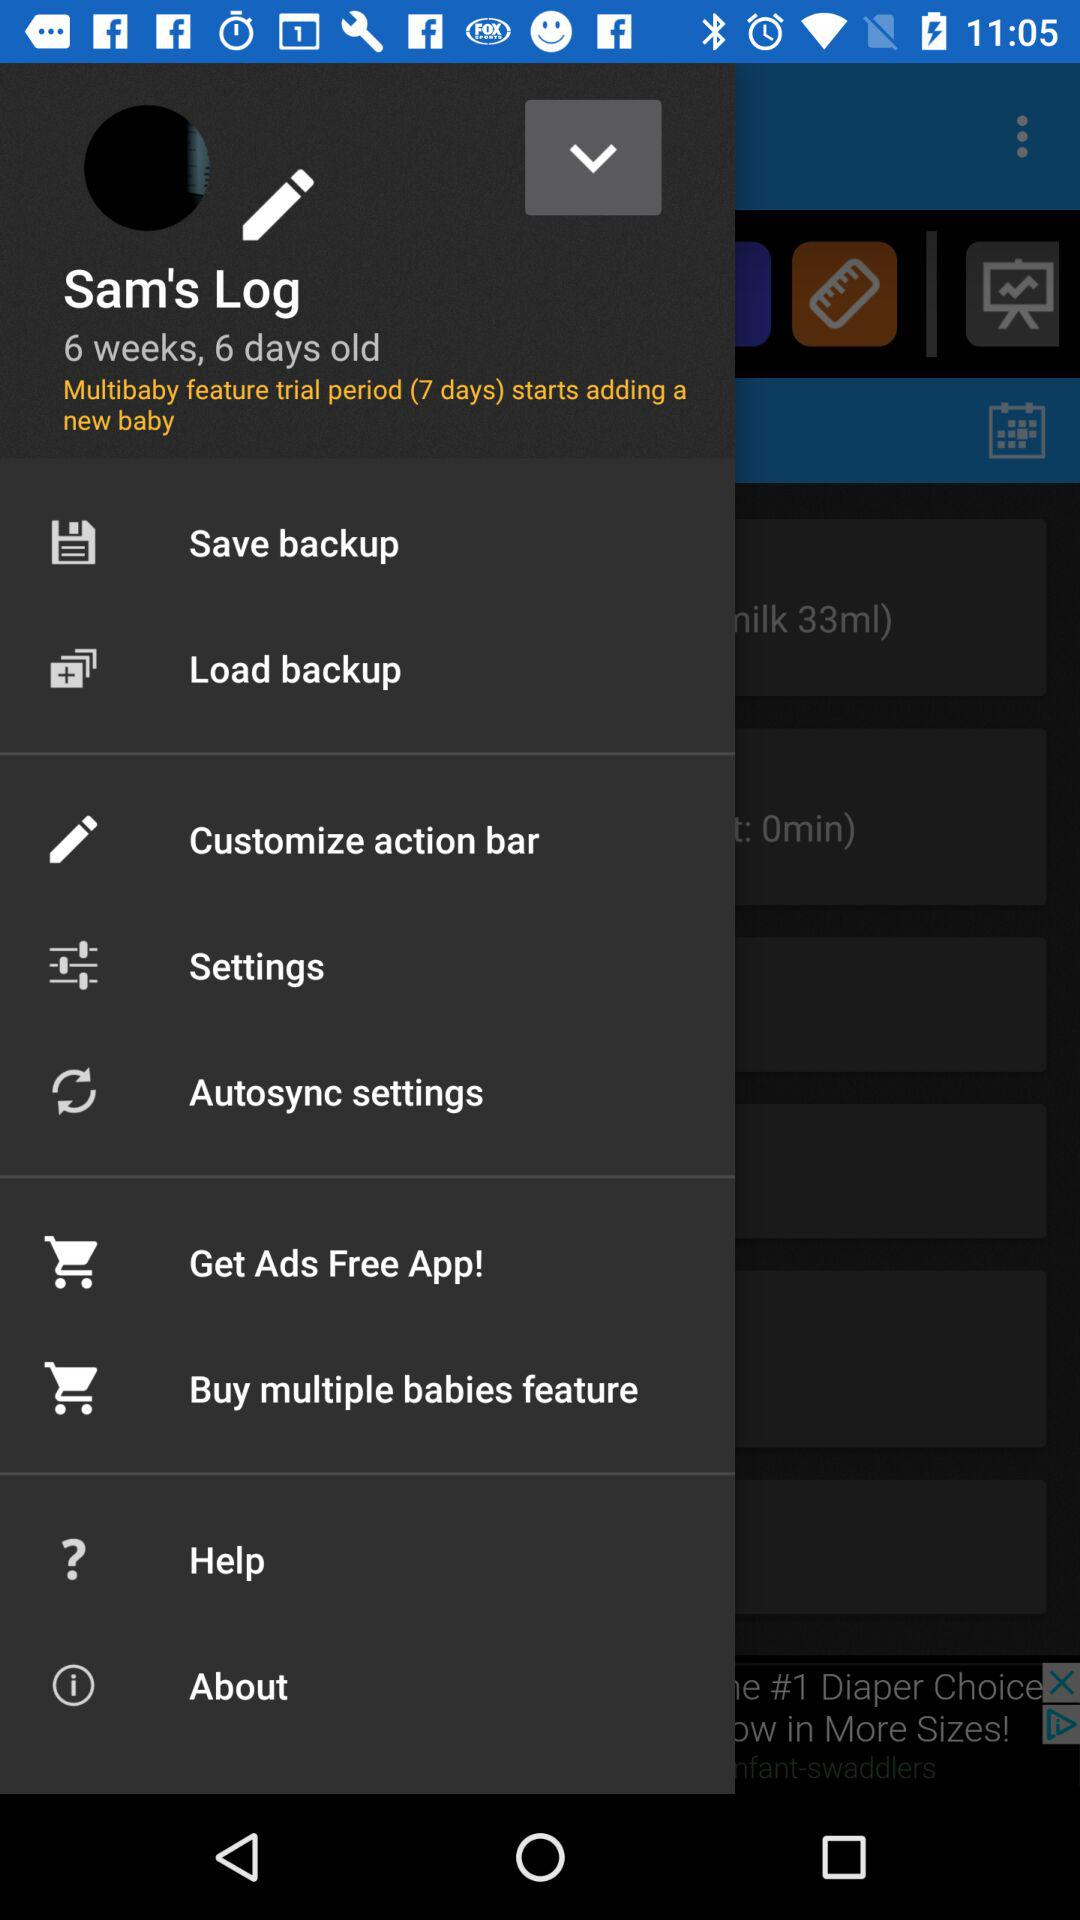How many weeks old is the baby? The baby is 6 weeks old. 